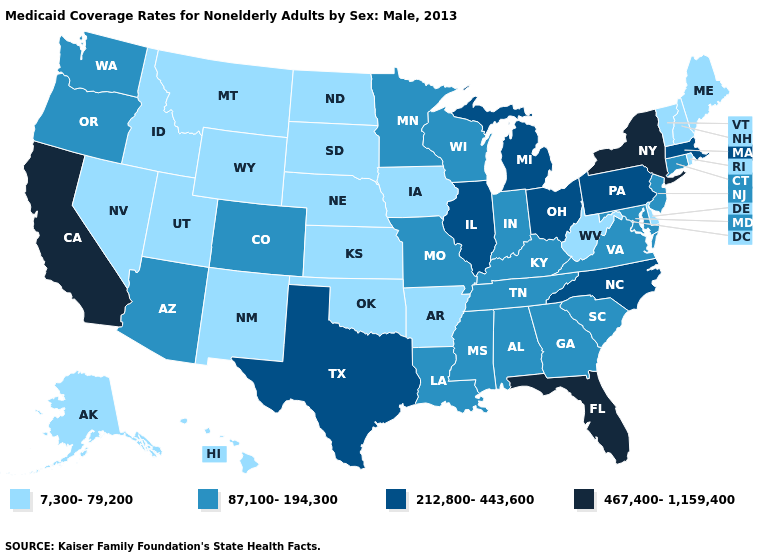Name the states that have a value in the range 467,400-1,159,400?
Keep it brief. California, Florida, New York. Name the states that have a value in the range 212,800-443,600?
Quick response, please. Illinois, Massachusetts, Michigan, North Carolina, Ohio, Pennsylvania, Texas. Among the states that border New Jersey , does Delaware have the lowest value?
Concise answer only. Yes. What is the lowest value in the West?
Give a very brief answer. 7,300-79,200. Name the states that have a value in the range 87,100-194,300?
Concise answer only. Alabama, Arizona, Colorado, Connecticut, Georgia, Indiana, Kentucky, Louisiana, Maryland, Minnesota, Mississippi, Missouri, New Jersey, Oregon, South Carolina, Tennessee, Virginia, Washington, Wisconsin. What is the value of Virginia?
Be succinct. 87,100-194,300. What is the value of Tennessee?
Keep it brief. 87,100-194,300. Does South Carolina have the same value as Michigan?
Keep it brief. No. Among the states that border Georgia , does North Carolina have the highest value?
Keep it brief. No. What is the value of Maine?
Short answer required. 7,300-79,200. Does Vermont have the lowest value in the USA?
Concise answer only. Yes. What is the value of Pennsylvania?
Keep it brief. 212,800-443,600. How many symbols are there in the legend?
Answer briefly. 4. Does Delaware have the same value as North Carolina?
Short answer required. No. Which states have the highest value in the USA?
Be succinct. California, Florida, New York. 